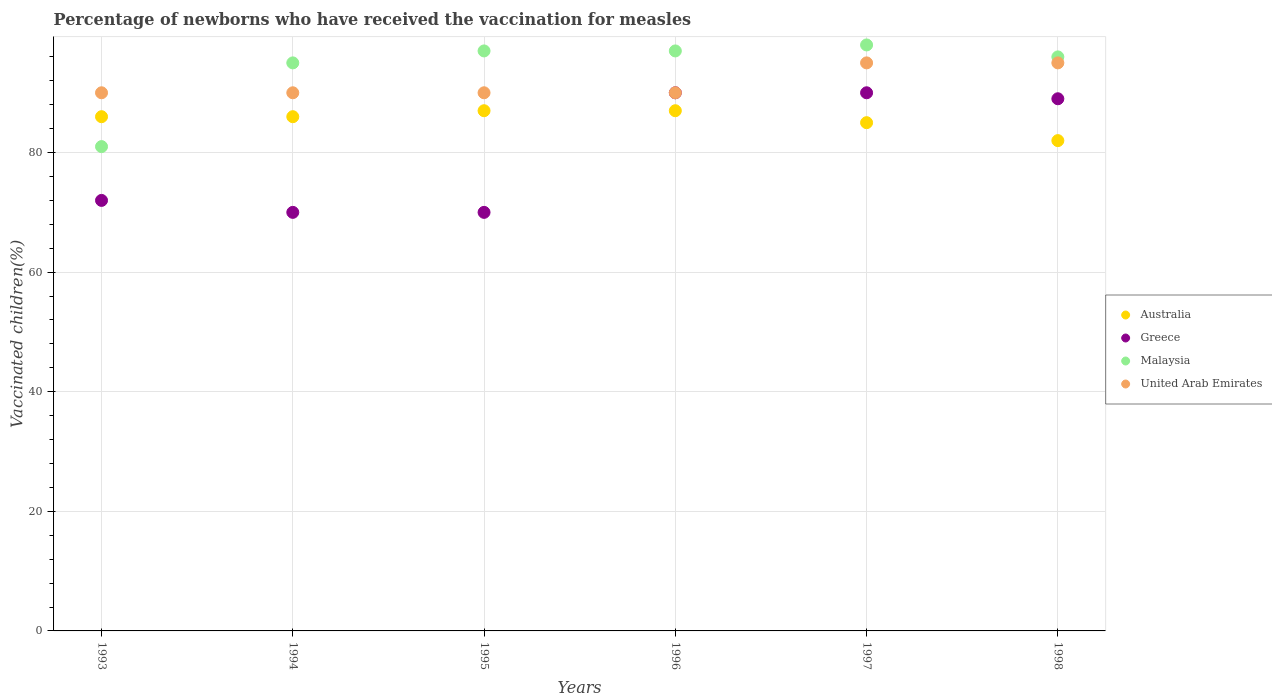How many different coloured dotlines are there?
Offer a very short reply. 4. Is the number of dotlines equal to the number of legend labels?
Keep it short and to the point. Yes. Across all years, what is the maximum percentage of vaccinated children in Malaysia?
Offer a terse response. 98. In which year was the percentage of vaccinated children in Greece minimum?
Your answer should be very brief. 1994. What is the total percentage of vaccinated children in Malaysia in the graph?
Your answer should be very brief. 564. What is the difference between the percentage of vaccinated children in Greece in 1997 and that in 1998?
Provide a short and direct response. 1. What is the difference between the percentage of vaccinated children in Greece in 1994 and the percentage of vaccinated children in Australia in 1996?
Give a very brief answer. -17. What is the average percentage of vaccinated children in Malaysia per year?
Your answer should be compact. 94. In the year 1994, what is the difference between the percentage of vaccinated children in Greece and percentage of vaccinated children in United Arab Emirates?
Keep it short and to the point. -20. In how many years, is the percentage of vaccinated children in Malaysia greater than 32 %?
Offer a very short reply. 6. What is the ratio of the percentage of vaccinated children in Australia in 1994 to that in 1997?
Provide a succinct answer. 1.01. Is the percentage of vaccinated children in Malaysia in 1994 less than that in 1995?
Make the answer very short. Yes. What is the difference between the highest and the lowest percentage of vaccinated children in Australia?
Provide a succinct answer. 5. In how many years, is the percentage of vaccinated children in Greece greater than the average percentage of vaccinated children in Greece taken over all years?
Give a very brief answer. 3. Is the sum of the percentage of vaccinated children in Malaysia in 1994 and 1997 greater than the maximum percentage of vaccinated children in United Arab Emirates across all years?
Offer a terse response. Yes. Is the percentage of vaccinated children in United Arab Emirates strictly greater than the percentage of vaccinated children in Malaysia over the years?
Keep it short and to the point. No. What is the difference between two consecutive major ticks on the Y-axis?
Ensure brevity in your answer.  20. Are the values on the major ticks of Y-axis written in scientific E-notation?
Make the answer very short. No. What is the title of the graph?
Provide a short and direct response. Percentage of newborns who have received the vaccination for measles. What is the label or title of the Y-axis?
Provide a succinct answer. Vaccinated children(%). What is the Vaccinated children(%) of Greece in 1993?
Keep it short and to the point. 72. What is the Vaccinated children(%) in Greece in 1994?
Ensure brevity in your answer.  70. What is the Vaccinated children(%) of Malaysia in 1994?
Your response must be concise. 95. What is the Vaccinated children(%) of Greece in 1995?
Your response must be concise. 70. What is the Vaccinated children(%) in Malaysia in 1995?
Keep it short and to the point. 97. What is the Vaccinated children(%) of United Arab Emirates in 1995?
Give a very brief answer. 90. What is the Vaccinated children(%) of Greece in 1996?
Make the answer very short. 90. What is the Vaccinated children(%) in Malaysia in 1996?
Your answer should be very brief. 97. What is the Vaccinated children(%) of Australia in 1997?
Make the answer very short. 85. What is the Vaccinated children(%) in Greece in 1997?
Keep it short and to the point. 90. What is the Vaccinated children(%) in United Arab Emirates in 1997?
Make the answer very short. 95. What is the Vaccinated children(%) in Australia in 1998?
Ensure brevity in your answer.  82. What is the Vaccinated children(%) of Greece in 1998?
Offer a terse response. 89. What is the Vaccinated children(%) in Malaysia in 1998?
Offer a terse response. 96. Across all years, what is the maximum Vaccinated children(%) of Greece?
Offer a terse response. 90. Across all years, what is the maximum Vaccinated children(%) in United Arab Emirates?
Your answer should be compact. 95. Across all years, what is the minimum Vaccinated children(%) in United Arab Emirates?
Your answer should be very brief. 90. What is the total Vaccinated children(%) of Australia in the graph?
Give a very brief answer. 513. What is the total Vaccinated children(%) in Greece in the graph?
Give a very brief answer. 481. What is the total Vaccinated children(%) of Malaysia in the graph?
Ensure brevity in your answer.  564. What is the total Vaccinated children(%) of United Arab Emirates in the graph?
Give a very brief answer. 550. What is the difference between the Vaccinated children(%) in Greece in 1993 and that in 1994?
Offer a terse response. 2. What is the difference between the Vaccinated children(%) of United Arab Emirates in 1993 and that in 1994?
Give a very brief answer. 0. What is the difference between the Vaccinated children(%) in Australia in 1993 and that in 1995?
Provide a succinct answer. -1. What is the difference between the Vaccinated children(%) in Greece in 1993 and that in 1995?
Offer a very short reply. 2. What is the difference between the Vaccinated children(%) in Malaysia in 1993 and that in 1995?
Your answer should be very brief. -16. What is the difference between the Vaccinated children(%) in Australia in 1993 and that in 1996?
Ensure brevity in your answer.  -1. What is the difference between the Vaccinated children(%) of Greece in 1993 and that in 1997?
Offer a terse response. -18. What is the difference between the Vaccinated children(%) in United Arab Emirates in 1993 and that in 1998?
Ensure brevity in your answer.  -5. What is the difference between the Vaccinated children(%) of Malaysia in 1994 and that in 1995?
Keep it short and to the point. -2. What is the difference between the Vaccinated children(%) in United Arab Emirates in 1994 and that in 1995?
Your answer should be very brief. 0. What is the difference between the Vaccinated children(%) in Australia in 1994 and that in 1996?
Your response must be concise. -1. What is the difference between the Vaccinated children(%) in Greece in 1994 and that in 1996?
Offer a terse response. -20. What is the difference between the Vaccinated children(%) of Malaysia in 1994 and that in 1996?
Make the answer very short. -2. What is the difference between the Vaccinated children(%) of United Arab Emirates in 1994 and that in 1996?
Your answer should be very brief. 0. What is the difference between the Vaccinated children(%) of Greece in 1994 and that in 1997?
Provide a short and direct response. -20. What is the difference between the Vaccinated children(%) of Malaysia in 1994 and that in 1997?
Offer a very short reply. -3. What is the difference between the Vaccinated children(%) in Greece in 1994 and that in 1998?
Offer a terse response. -19. What is the difference between the Vaccinated children(%) of United Arab Emirates in 1994 and that in 1998?
Give a very brief answer. -5. What is the difference between the Vaccinated children(%) of Australia in 1995 and that in 1997?
Give a very brief answer. 2. What is the difference between the Vaccinated children(%) in Greece in 1995 and that in 1997?
Your answer should be compact. -20. What is the difference between the Vaccinated children(%) in Greece in 1995 and that in 1998?
Offer a very short reply. -19. What is the difference between the Vaccinated children(%) of Malaysia in 1995 and that in 1998?
Ensure brevity in your answer.  1. What is the difference between the Vaccinated children(%) of Australia in 1996 and that in 1997?
Offer a very short reply. 2. What is the difference between the Vaccinated children(%) of Greece in 1996 and that in 1997?
Ensure brevity in your answer.  0. What is the difference between the Vaccinated children(%) in Greece in 1996 and that in 1998?
Offer a very short reply. 1. What is the difference between the Vaccinated children(%) of Malaysia in 1996 and that in 1998?
Ensure brevity in your answer.  1. What is the difference between the Vaccinated children(%) in Australia in 1997 and that in 1998?
Your answer should be very brief. 3. What is the difference between the Vaccinated children(%) in Australia in 1993 and the Vaccinated children(%) in Greece in 1994?
Ensure brevity in your answer.  16. What is the difference between the Vaccinated children(%) of Australia in 1993 and the Vaccinated children(%) of Malaysia in 1994?
Make the answer very short. -9. What is the difference between the Vaccinated children(%) of Australia in 1993 and the Vaccinated children(%) of United Arab Emirates in 1994?
Give a very brief answer. -4. What is the difference between the Vaccinated children(%) in Greece in 1993 and the Vaccinated children(%) in Malaysia in 1994?
Make the answer very short. -23. What is the difference between the Vaccinated children(%) in Greece in 1993 and the Vaccinated children(%) in United Arab Emirates in 1994?
Provide a succinct answer. -18. What is the difference between the Vaccinated children(%) of Malaysia in 1993 and the Vaccinated children(%) of United Arab Emirates in 1994?
Offer a terse response. -9. What is the difference between the Vaccinated children(%) in Australia in 1993 and the Vaccinated children(%) in United Arab Emirates in 1995?
Keep it short and to the point. -4. What is the difference between the Vaccinated children(%) in Australia in 1993 and the Vaccinated children(%) in Malaysia in 1996?
Give a very brief answer. -11. What is the difference between the Vaccinated children(%) in Australia in 1993 and the Vaccinated children(%) in United Arab Emirates in 1996?
Provide a succinct answer. -4. What is the difference between the Vaccinated children(%) in Australia in 1993 and the Vaccinated children(%) in Greece in 1997?
Your answer should be very brief. -4. What is the difference between the Vaccinated children(%) of Australia in 1993 and the Vaccinated children(%) of Malaysia in 1997?
Ensure brevity in your answer.  -12. What is the difference between the Vaccinated children(%) of Malaysia in 1993 and the Vaccinated children(%) of United Arab Emirates in 1997?
Make the answer very short. -14. What is the difference between the Vaccinated children(%) of Australia in 1993 and the Vaccinated children(%) of Greece in 1998?
Offer a very short reply. -3. What is the difference between the Vaccinated children(%) in Malaysia in 1993 and the Vaccinated children(%) in United Arab Emirates in 1998?
Your response must be concise. -14. What is the difference between the Vaccinated children(%) in Australia in 1994 and the Vaccinated children(%) in Greece in 1995?
Make the answer very short. 16. What is the difference between the Vaccinated children(%) in Australia in 1994 and the Vaccinated children(%) in Malaysia in 1995?
Provide a short and direct response. -11. What is the difference between the Vaccinated children(%) in Australia in 1994 and the Vaccinated children(%) in United Arab Emirates in 1995?
Provide a succinct answer. -4. What is the difference between the Vaccinated children(%) in Greece in 1994 and the Vaccinated children(%) in Malaysia in 1995?
Your response must be concise. -27. What is the difference between the Vaccinated children(%) of Malaysia in 1994 and the Vaccinated children(%) of United Arab Emirates in 1995?
Ensure brevity in your answer.  5. What is the difference between the Vaccinated children(%) in Greece in 1994 and the Vaccinated children(%) in Malaysia in 1996?
Your answer should be compact. -27. What is the difference between the Vaccinated children(%) in Greece in 1994 and the Vaccinated children(%) in United Arab Emirates in 1996?
Ensure brevity in your answer.  -20. What is the difference between the Vaccinated children(%) in Malaysia in 1994 and the Vaccinated children(%) in United Arab Emirates in 1996?
Give a very brief answer. 5. What is the difference between the Vaccinated children(%) of Australia in 1994 and the Vaccinated children(%) of Malaysia in 1997?
Ensure brevity in your answer.  -12. What is the difference between the Vaccinated children(%) in Australia in 1994 and the Vaccinated children(%) in United Arab Emirates in 1997?
Make the answer very short. -9. What is the difference between the Vaccinated children(%) of Greece in 1994 and the Vaccinated children(%) of Malaysia in 1997?
Your response must be concise. -28. What is the difference between the Vaccinated children(%) in Greece in 1994 and the Vaccinated children(%) in United Arab Emirates in 1997?
Keep it short and to the point. -25. What is the difference between the Vaccinated children(%) of Malaysia in 1994 and the Vaccinated children(%) of United Arab Emirates in 1997?
Keep it short and to the point. 0. What is the difference between the Vaccinated children(%) of Australia in 1994 and the Vaccinated children(%) of Greece in 1998?
Make the answer very short. -3. What is the difference between the Vaccinated children(%) of Australia in 1994 and the Vaccinated children(%) of United Arab Emirates in 1998?
Keep it short and to the point. -9. What is the difference between the Vaccinated children(%) in Greece in 1994 and the Vaccinated children(%) in United Arab Emirates in 1998?
Your answer should be very brief. -25. What is the difference between the Vaccinated children(%) in Australia in 1995 and the Vaccinated children(%) in Malaysia in 1996?
Your answer should be compact. -10. What is the difference between the Vaccinated children(%) of Greece in 1995 and the Vaccinated children(%) of United Arab Emirates in 1996?
Offer a very short reply. -20. What is the difference between the Vaccinated children(%) of Australia in 1995 and the Vaccinated children(%) of Greece in 1997?
Your answer should be very brief. -3. What is the difference between the Vaccinated children(%) of Greece in 1995 and the Vaccinated children(%) of United Arab Emirates in 1997?
Your response must be concise. -25. What is the difference between the Vaccinated children(%) of Australia in 1995 and the Vaccinated children(%) of Malaysia in 1998?
Your answer should be very brief. -9. What is the difference between the Vaccinated children(%) of Australia in 1996 and the Vaccinated children(%) of Greece in 1997?
Give a very brief answer. -3. What is the difference between the Vaccinated children(%) of Australia in 1996 and the Vaccinated children(%) of Malaysia in 1997?
Your answer should be very brief. -11. What is the difference between the Vaccinated children(%) in Greece in 1996 and the Vaccinated children(%) in United Arab Emirates in 1997?
Offer a terse response. -5. What is the difference between the Vaccinated children(%) in Australia in 1996 and the Vaccinated children(%) in Malaysia in 1998?
Offer a very short reply. -9. What is the difference between the Vaccinated children(%) of Australia in 1996 and the Vaccinated children(%) of United Arab Emirates in 1998?
Your answer should be very brief. -8. What is the difference between the Vaccinated children(%) of Greece in 1996 and the Vaccinated children(%) of United Arab Emirates in 1998?
Your answer should be compact. -5. What is the difference between the Vaccinated children(%) of Australia in 1997 and the Vaccinated children(%) of Greece in 1998?
Offer a terse response. -4. What is the difference between the Vaccinated children(%) of Australia in 1997 and the Vaccinated children(%) of United Arab Emirates in 1998?
Offer a very short reply. -10. What is the difference between the Vaccinated children(%) of Malaysia in 1997 and the Vaccinated children(%) of United Arab Emirates in 1998?
Your answer should be very brief. 3. What is the average Vaccinated children(%) in Australia per year?
Your answer should be compact. 85.5. What is the average Vaccinated children(%) of Greece per year?
Offer a very short reply. 80.17. What is the average Vaccinated children(%) in Malaysia per year?
Make the answer very short. 94. What is the average Vaccinated children(%) in United Arab Emirates per year?
Keep it short and to the point. 91.67. In the year 1993, what is the difference between the Vaccinated children(%) of Australia and Vaccinated children(%) of Greece?
Your response must be concise. 14. In the year 1993, what is the difference between the Vaccinated children(%) in Greece and Vaccinated children(%) in Malaysia?
Your answer should be very brief. -9. In the year 1994, what is the difference between the Vaccinated children(%) in Australia and Vaccinated children(%) in Greece?
Your response must be concise. 16. In the year 1994, what is the difference between the Vaccinated children(%) of Australia and Vaccinated children(%) of United Arab Emirates?
Provide a short and direct response. -4. In the year 1994, what is the difference between the Vaccinated children(%) in Greece and Vaccinated children(%) in Malaysia?
Offer a terse response. -25. In the year 1994, what is the difference between the Vaccinated children(%) of Malaysia and Vaccinated children(%) of United Arab Emirates?
Offer a very short reply. 5. In the year 1995, what is the difference between the Vaccinated children(%) in Australia and Vaccinated children(%) in Malaysia?
Provide a succinct answer. -10. In the year 1995, what is the difference between the Vaccinated children(%) of Australia and Vaccinated children(%) of United Arab Emirates?
Your response must be concise. -3. In the year 1995, what is the difference between the Vaccinated children(%) of Greece and Vaccinated children(%) of United Arab Emirates?
Provide a succinct answer. -20. In the year 1995, what is the difference between the Vaccinated children(%) in Malaysia and Vaccinated children(%) in United Arab Emirates?
Provide a succinct answer. 7. In the year 1996, what is the difference between the Vaccinated children(%) in Australia and Vaccinated children(%) in Greece?
Make the answer very short. -3. In the year 1996, what is the difference between the Vaccinated children(%) in Australia and Vaccinated children(%) in Malaysia?
Keep it short and to the point. -10. In the year 1996, what is the difference between the Vaccinated children(%) in Greece and Vaccinated children(%) in Malaysia?
Offer a terse response. -7. In the year 1997, what is the difference between the Vaccinated children(%) in Australia and Vaccinated children(%) in Greece?
Your answer should be very brief. -5. In the year 1997, what is the difference between the Vaccinated children(%) of Malaysia and Vaccinated children(%) of United Arab Emirates?
Your answer should be very brief. 3. In the year 1998, what is the difference between the Vaccinated children(%) of Australia and Vaccinated children(%) of Greece?
Keep it short and to the point. -7. In the year 1998, what is the difference between the Vaccinated children(%) in Australia and Vaccinated children(%) in Malaysia?
Ensure brevity in your answer.  -14. In the year 1998, what is the difference between the Vaccinated children(%) in Australia and Vaccinated children(%) in United Arab Emirates?
Your answer should be compact. -13. In the year 1998, what is the difference between the Vaccinated children(%) of Greece and Vaccinated children(%) of Malaysia?
Ensure brevity in your answer.  -7. In the year 1998, what is the difference between the Vaccinated children(%) of Malaysia and Vaccinated children(%) of United Arab Emirates?
Offer a terse response. 1. What is the ratio of the Vaccinated children(%) of Australia in 1993 to that in 1994?
Keep it short and to the point. 1. What is the ratio of the Vaccinated children(%) of Greece in 1993 to that in 1994?
Your answer should be compact. 1.03. What is the ratio of the Vaccinated children(%) in Malaysia in 1993 to that in 1994?
Provide a succinct answer. 0.85. What is the ratio of the Vaccinated children(%) in Australia in 1993 to that in 1995?
Your answer should be compact. 0.99. What is the ratio of the Vaccinated children(%) of Greece in 1993 to that in 1995?
Provide a short and direct response. 1.03. What is the ratio of the Vaccinated children(%) of Malaysia in 1993 to that in 1995?
Your answer should be very brief. 0.84. What is the ratio of the Vaccinated children(%) of Malaysia in 1993 to that in 1996?
Your answer should be very brief. 0.84. What is the ratio of the Vaccinated children(%) in Australia in 1993 to that in 1997?
Provide a short and direct response. 1.01. What is the ratio of the Vaccinated children(%) in Greece in 1993 to that in 1997?
Provide a succinct answer. 0.8. What is the ratio of the Vaccinated children(%) in Malaysia in 1993 to that in 1997?
Provide a short and direct response. 0.83. What is the ratio of the Vaccinated children(%) of Australia in 1993 to that in 1998?
Offer a terse response. 1.05. What is the ratio of the Vaccinated children(%) in Greece in 1993 to that in 1998?
Ensure brevity in your answer.  0.81. What is the ratio of the Vaccinated children(%) of Malaysia in 1993 to that in 1998?
Give a very brief answer. 0.84. What is the ratio of the Vaccinated children(%) of Greece in 1994 to that in 1995?
Offer a very short reply. 1. What is the ratio of the Vaccinated children(%) of Malaysia in 1994 to that in 1995?
Ensure brevity in your answer.  0.98. What is the ratio of the Vaccinated children(%) in United Arab Emirates in 1994 to that in 1995?
Your answer should be compact. 1. What is the ratio of the Vaccinated children(%) in Australia in 1994 to that in 1996?
Give a very brief answer. 0.99. What is the ratio of the Vaccinated children(%) of Greece in 1994 to that in 1996?
Your answer should be very brief. 0.78. What is the ratio of the Vaccinated children(%) in Malaysia in 1994 to that in 1996?
Provide a succinct answer. 0.98. What is the ratio of the Vaccinated children(%) in United Arab Emirates in 1994 to that in 1996?
Offer a terse response. 1. What is the ratio of the Vaccinated children(%) of Australia in 1994 to that in 1997?
Offer a very short reply. 1.01. What is the ratio of the Vaccinated children(%) in Malaysia in 1994 to that in 1997?
Your answer should be compact. 0.97. What is the ratio of the Vaccinated children(%) of United Arab Emirates in 1994 to that in 1997?
Your response must be concise. 0.95. What is the ratio of the Vaccinated children(%) in Australia in 1994 to that in 1998?
Keep it short and to the point. 1.05. What is the ratio of the Vaccinated children(%) of Greece in 1994 to that in 1998?
Offer a terse response. 0.79. What is the ratio of the Vaccinated children(%) of United Arab Emirates in 1994 to that in 1998?
Your response must be concise. 0.95. What is the ratio of the Vaccinated children(%) of Greece in 1995 to that in 1996?
Ensure brevity in your answer.  0.78. What is the ratio of the Vaccinated children(%) of Malaysia in 1995 to that in 1996?
Provide a succinct answer. 1. What is the ratio of the Vaccinated children(%) of Australia in 1995 to that in 1997?
Give a very brief answer. 1.02. What is the ratio of the Vaccinated children(%) of Australia in 1995 to that in 1998?
Offer a very short reply. 1.06. What is the ratio of the Vaccinated children(%) of Greece in 1995 to that in 1998?
Keep it short and to the point. 0.79. What is the ratio of the Vaccinated children(%) of Malaysia in 1995 to that in 1998?
Keep it short and to the point. 1.01. What is the ratio of the Vaccinated children(%) of Australia in 1996 to that in 1997?
Provide a short and direct response. 1.02. What is the ratio of the Vaccinated children(%) in Malaysia in 1996 to that in 1997?
Give a very brief answer. 0.99. What is the ratio of the Vaccinated children(%) in United Arab Emirates in 1996 to that in 1997?
Keep it short and to the point. 0.95. What is the ratio of the Vaccinated children(%) in Australia in 1996 to that in 1998?
Offer a terse response. 1.06. What is the ratio of the Vaccinated children(%) in Greece in 1996 to that in 1998?
Provide a short and direct response. 1.01. What is the ratio of the Vaccinated children(%) of Malaysia in 1996 to that in 1998?
Provide a succinct answer. 1.01. What is the ratio of the Vaccinated children(%) of Australia in 1997 to that in 1998?
Your answer should be compact. 1.04. What is the ratio of the Vaccinated children(%) of Greece in 1997 to that in 1998?
Make the answer very short. 1.01. What is the ratio of the Vaccinated children(%) of Malaysia in 1997 to that in 1998?
Your answer should be very brief. 1.02. What is the ratio of the Vaccinated children(%) in United Arab Emirates in 1997 to that in 1998?
Provide a short and direct response. 1. What is the difference between the highest and the second highest Vaccinated children(%) in Australia?
Offer a terse response. 0. What is the difference between the highest and the second highest Vaccinated children(%) in Greece?
Offer a terse response. 0. What is the difference between the highest and the lowest Vaccinated children(%) in Australia?
Your answer should be compact. 5. What is the difference between the highest and the lowest Vaccinated children(%) in Malaysia?
Keep it short and to the point. 17. 